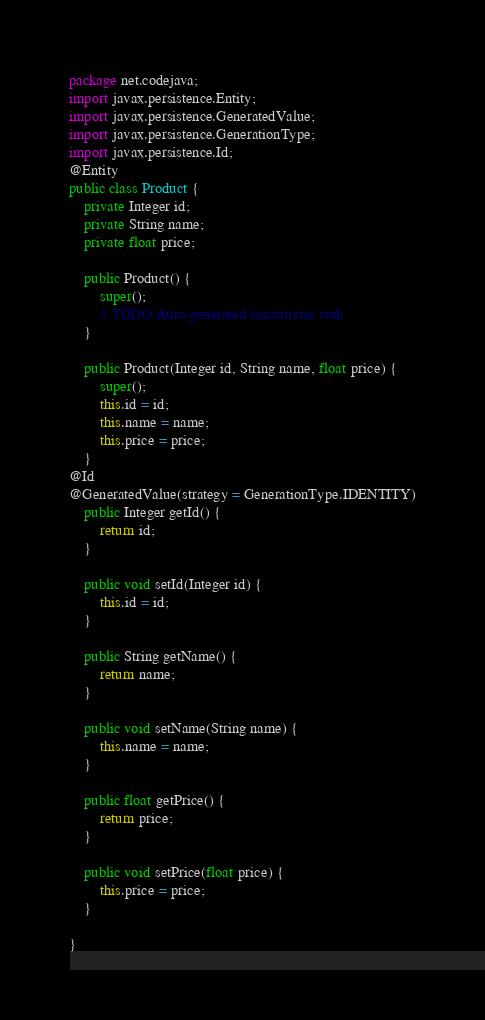Convert code to text. <code><loc_0><loc_0><loc_500><loc_500><_Java_>package net.codejava;
import javax.persistence.Entity;
import javax.persistence.GeneratedValue;
import javax.persistence.GenerationType;
import javax.persistence.Id;
@Entity
public class Product {
	private Integer id;
	private String name;
	private float price;

	public Product() {
		super();
		// TODO Auto-generated constructor stub
	}

	public Product(Integer id, String name, float price) {
		super();
		this.id = id;
		this.name = name;
		this.price = price;
	}
@Id
@GeneratedValue(strategy = GenerationType.IDENTITY)
	public Integer getId() {
		return id;
	}

	public void setId(Integer id) {
		this.id = id;
	}

	public String getName() {
		return name;
	}

	public void setName(String name) {
		this.name = name;
	}

	public float getPrice() {
		return price;
	}

	public void setPrice(float price) {
		this.price = price;
	}

}
</code> 